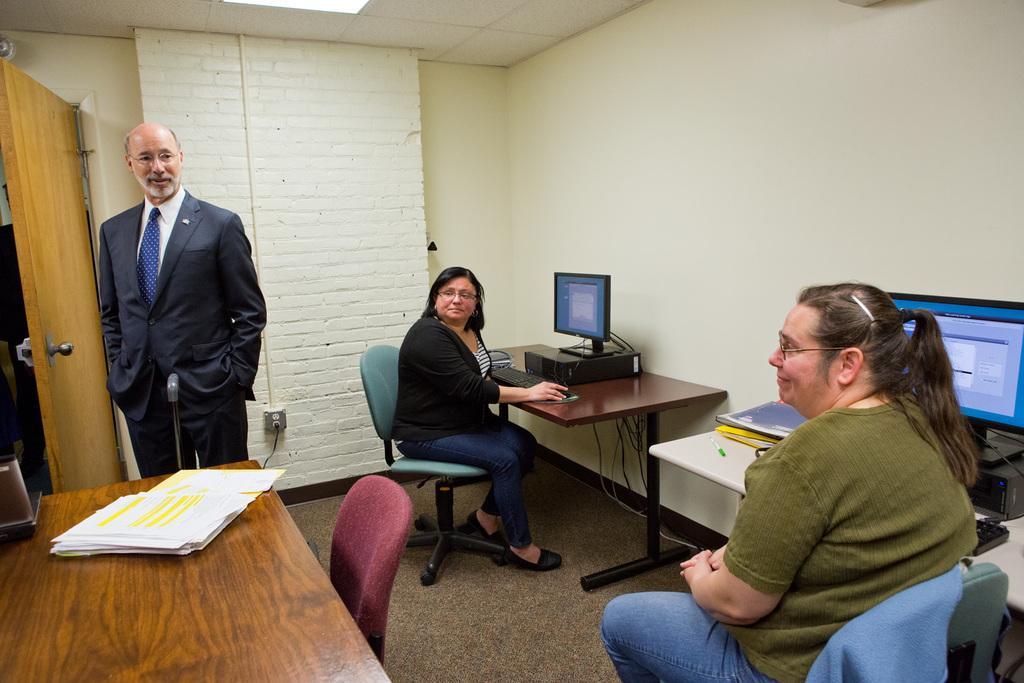Please provide a concise description of this image. As we can see in the image there is a white color wall, three people over here and there is a table. On table there are laptops. On the left side there is another table. On this table there are papers. 